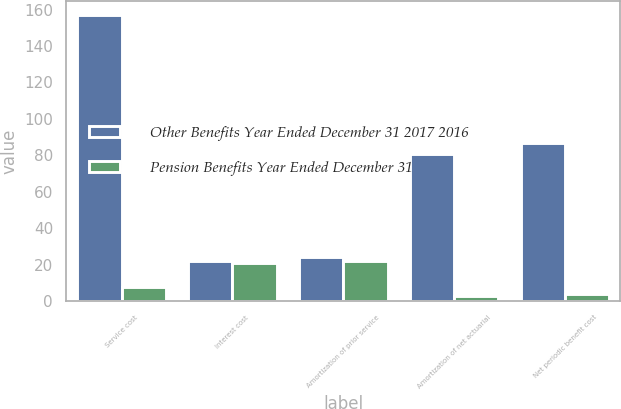<chart> <loc_0><loc_0><loc_500><loc_500><stacked_bar_chart><ecel><fcel>Service cost<fcel>Interest cost<fcel>Amortization of prior service<fcel>Amortization of net actuarial<fcel>Net periodic benefit cost<nl><fcel>Other Benefits Year Ended December 31 2017 2016<fcel>157<fcel>22<fcel>24<fcel>81<fcel>87<nl><fcel>Pension Benefits Year Ended December 31<fcel>8<fcel>21<fcel>22<fcel>3<fcel>4<nl></chart> 